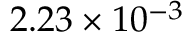<formula> <loc_0><loc_0><loc_500><loc_500>2 . 2 3 \times 1 0 ^ { - 3 }</formula> 